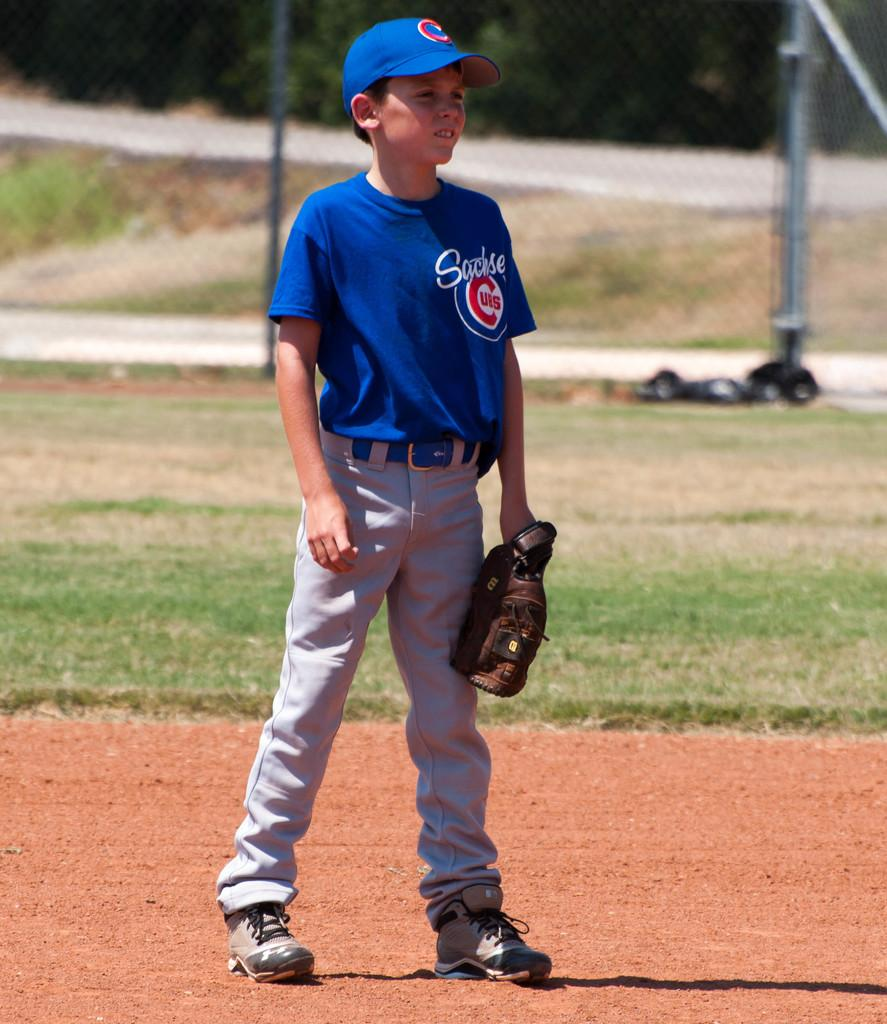<image>
Give a short and clear explanation of the subsequent image. a little boy in a basball uniform from the teamsactise 